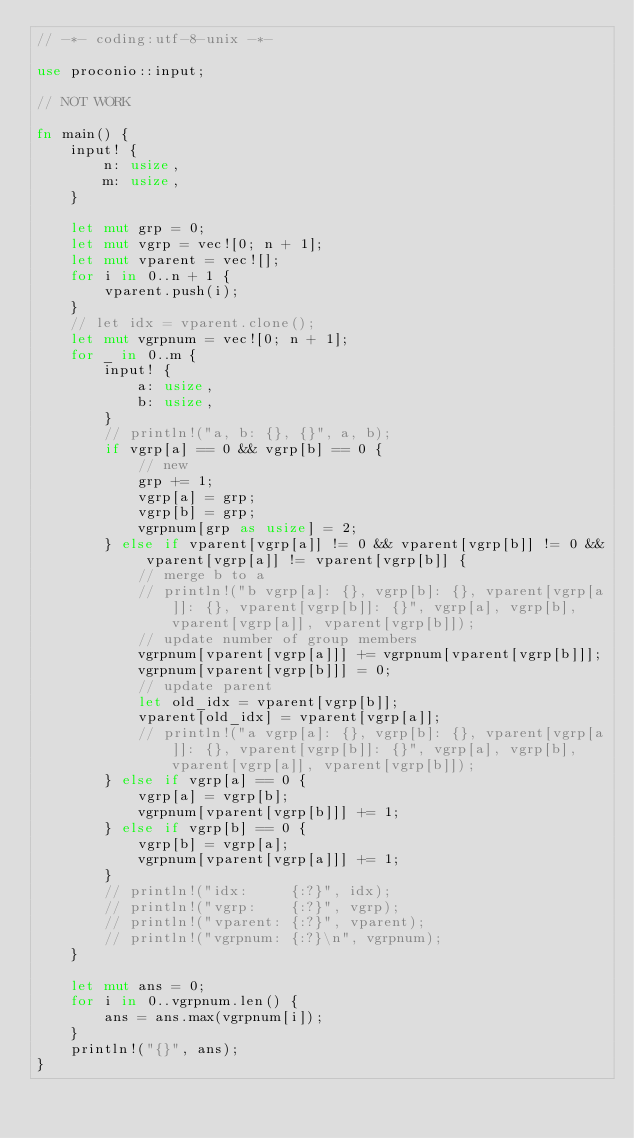Convert code to text. <code><loc_0><loc_0><loc_500><loc_500><_Rust_>// -*- coding:utf-8-unix -*-

use proconio::input;

// NOT WORK

fn main() {
    input! {
        n: usize,
        m: usize,
    }

    let mut grp = 0;
    let mut vgrp = vec![0; n + 1];
    let mut vparent = vec![];
    for i in 0..n + 1 {
        vparent.push(i);
    }
    // let idx = vparent.clone();
    let mut vgrpnum = vec![0; n + 1];
    for _ in 0..m {
        input! {
            a: usize,
            b: usize,
        }
        // println!("a, b: {}, {}", a, b);
        if vgrp[a] == 0 && vgrp[b] == 0 {
            // new
            grp += 1;
            vgrp[a] = grp;
            vgrp[b] = grp;
            vgrpnum[grp as usize] = 2;
        } else if vparent[vgrp[a]] != 0 && vparent[vgrp[b]] != 0 && vparent[vgrp[a]] != vparent[vgrp[b]] {
            // merge b to a
            // println!("b vgrp[a]: {}, vgrp[b]: {}, vparent[vgrp[a]]: {}, vparent[vgrp[b]]: {}", vgrp[a], vgrp[b], vparent[vgrp[a]], vparent[vgrp[b]]);
            // update number of group members
            vgrpnum[vparent[vgrp[a]]] += vgrpnum[vparent[vgrp[b]]];
            vgrpnum[vparent[vgrp[b]]] = 0;
            // update parent
            let old_idx = vparent[vgrp[b]];
            vparent[old_idx] = vparent[vgrp[a]];
            // println!("a vgrp[a]: {}, vgrp[b]: {}, vparent[vgrp[a]]: {}, vparent[vgrp[b]]: {}", vgrp[a], vgrp[b], vparent[vgrp[a]], vparent[vgrp[b]]);
        } else if vgrp[a] == 0 {
            vgrp[a] = vgrp[b];
            vgrpnum[vparent[vgrp[b]]] += 1;
        } else if vgrp[b] == 0 {
            vgrp[b] = vgrp[a];
            vgrpnum[vparent[vgrp[a]]] += 1;
        }
        // println!("idx:     {:?}", idx);
        // println!("vgrp:    {:?}", vgrp);
        // println!("vparent: {:?}", vparent);
        // println!("vgrpnum: {:?}\n", vgrpnum);
    }

    let mut ans = 0;
    for i in 0..vgrpnum.len() {
        ans = ans.max(vgrpnum[i]);
    }
    println!("{}", ans);
}
</code> 